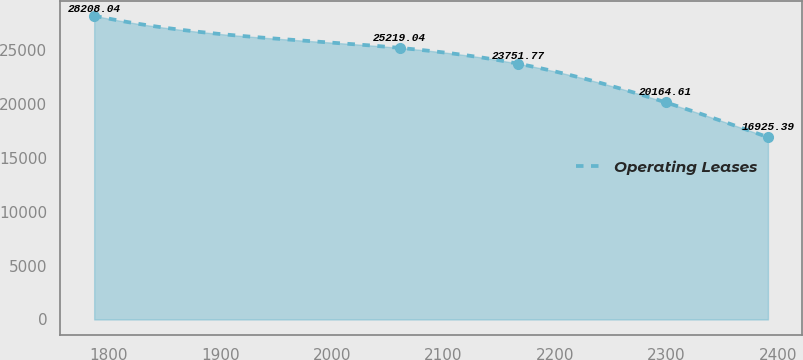<chart> <loc_0><loc_0><loc_500><loc_500><line_chart><ecel><fcel>Operating Leases<nl><fcel>1786.69<fcel>28208<nl><fcel>2060.82<fcel>25219<nl><fcel>2167.09<fcel>23751.8<nl><fcel>2299.34<fcel>20164.6<nl><fcel>2391.19<fcel>16925.4<nl></chart> 